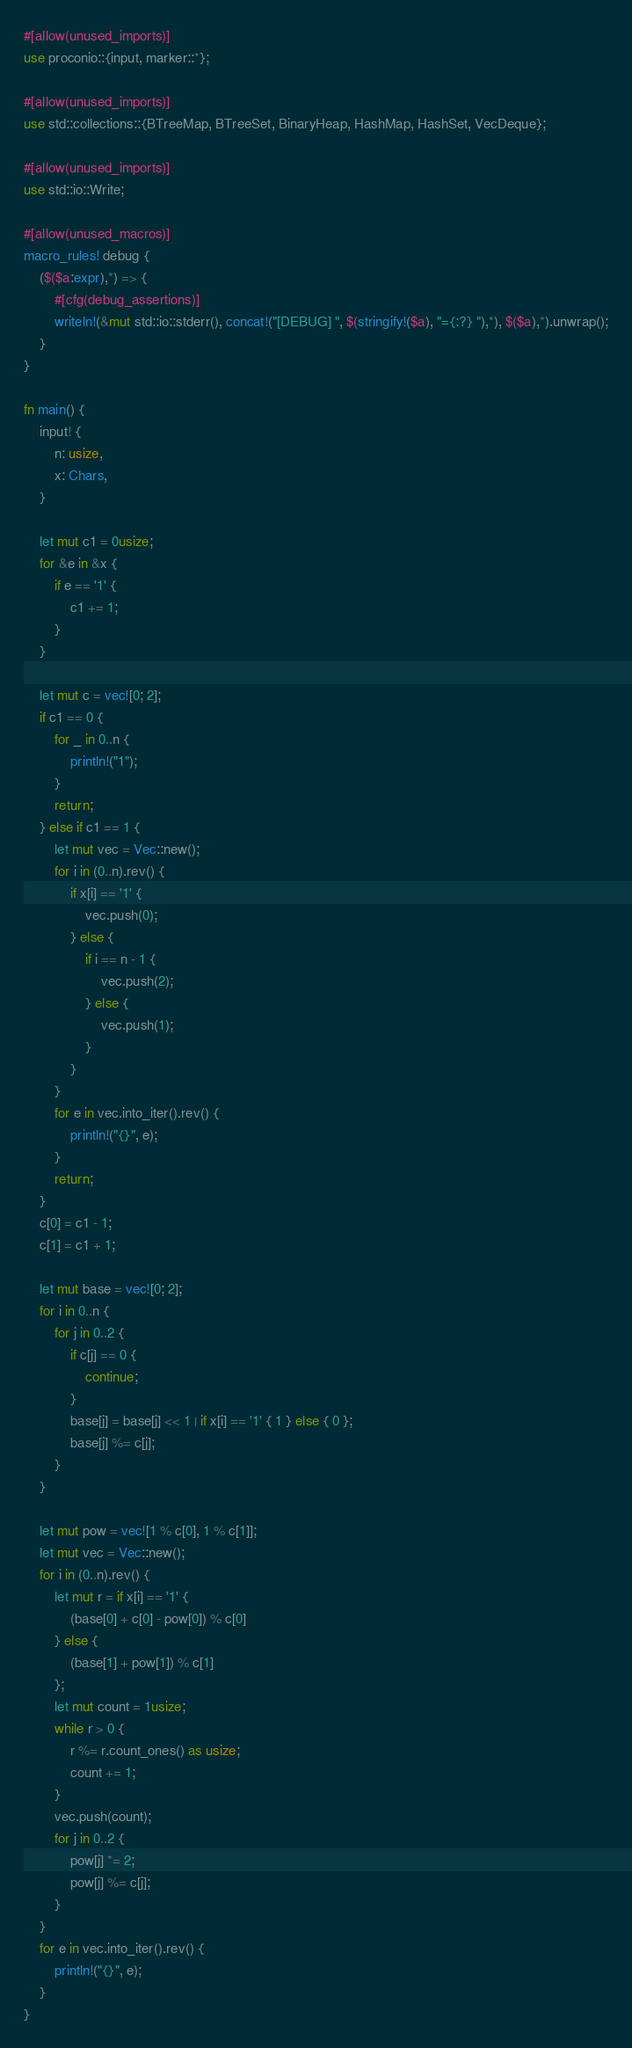<code> <loc_0><loc_0><loc_500><loc_500><_Rust_>#[allow(unused_imports)]
use proconio::{input, marker::*};

#[allow(unused_imports)]
use std::collections::{BTreeMap, BTreeSet, BinaryHeap, HashMap, HashSet, VecDeque};

#[allow(unused_imports)]
use std::io::Write;

#[allow(unused_macros)]
macro_rules! debug {
    ($($a:expr),*) => {
        #[cfg(debug_assertions)]
        writeln!(&mut std::io::stderr(), concat!("[DEBUG] ", $(stringify!($a), "={:?} "),*), $($a),*).unwrap();
    }
}

fn main() {
    input! {
        n: usize,
        x: Chars,
    }

    let mut c1 = 0usize;
    for &e in &x {
        if e == '1' {
            c1 += 1;
        }
    }

    let mut c = vec![0; 2];
    if c1 == 0 {
        for _ in 0..n {
            println!("1");
        }
        return;
    } else if c1 == 1 {
        let mut vec = Vec::new();
        for i in (0..n).rev() {
            if x[i] == '1' {
                vec.push(0);
            } else {
                if i == n - 1 {
                    vec.push(2);
                } else {
                    vec.push(1);
                }
            }
        }
        for e in vec.into_iter().rev() {
            println!("{}", e);
        }
        return;
    }
    c[0] = c1 - 1;
    c[1] = c1 + 1;

    let mut base = vec![0; 2];
    for i in 0..n {
        for j in 0..2 {
            if c[j] == 0 {
                continue;
            }
            base[j] = base[j] << 1 | if x[i] == '1' { 1 } else { 0 };
            base[j] %= c[j];
        }
    }

    let mut pow = vec![1 % c[0], 1 % c[1]];
    let mut vec = Vec::new();
    for i in (0..n).rev() {
        let mut r = if x[i] == '1' {
            (base[0] + c[0] - pow[0]) % c[0]
        } else {
            (base[1] + pow[1]) % c[1]
        };
        let mut count = 1usize;
        while r > 0 {
            r %= r.count_ones() as usize;
            count += 1;
        }
        vec.push(count);
        for j in 0..2 {
            pow[j] *= 2;
            pow[j] %= c[j];
        }
    }
    for e in vec.into_iter().rev() {
        println!("{}", e);
    }
}
</code> 